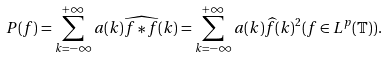<formula> <loc_0><loc_0><loc_500><loc_500>P ( f ) = \sum _ { k = - \infty } ^ { + \infty } a ( k ) \widehat { f \ast f } ( k ) = \sum _ { k = - \infty } ^ { + \infty } a ( k ) \widehat { f } ( k ) ^ { 2 } ( f \in L ^ { p } ( \mathbb { T } ) ) .</formula> 